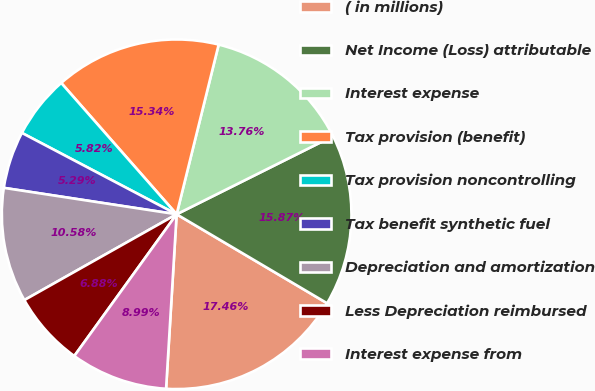<chart> <loc_0><loc_0><loc_500><loc_500><pie_chart><fcel>( in millions)<fcel>Net Income (Loss) attributable<fcel>Interest expense<fcel>Tax provision (benefit)<fcel>Tax provision noncontrolling<fcel>Tax benefit synthetic fuel<fcel>Depreciation and amortization<fcel>Less Depreciation reimbursed<fcel>Interest expense from<nl><fcel>17.46%<fcel>15.87%<fcel>13.76%<fcel>15.34%<fcel>5.82%<fcel>5.29%<fcel>10.58%<fcel>6.88%<fcel>8.99%<nl></chart> 